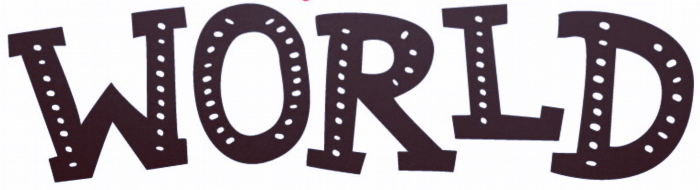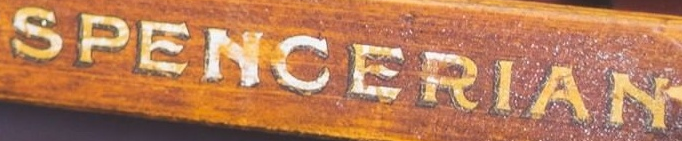What text is displayed in these images sequentially, separated by a semicolon? WORLD; SPENCERIAN 